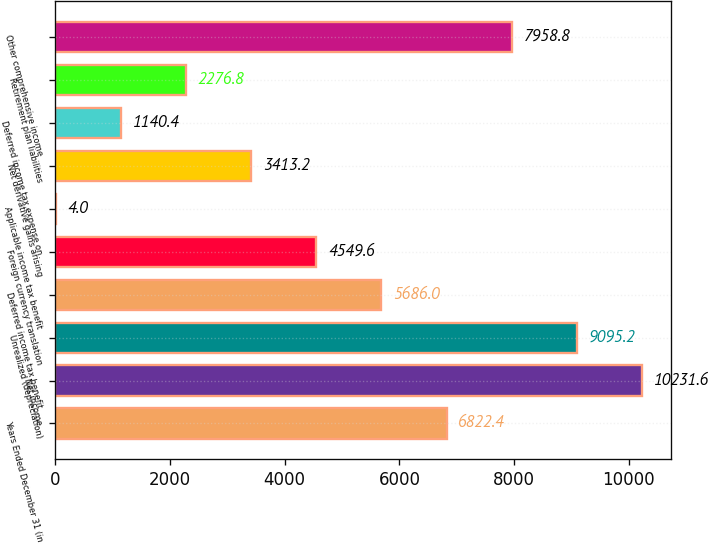Convert chart. <chart><loc_0><loc_0><loc_500><loc_500><bar_chart><fcel>Years Ended December 31 (in<fcel>Net income<fcel>Unrealized (depreciation)<fcel>Deferred income tax benefit<fcel>Foreign currency translation<fcel>Applicable income tax benefit<fcel>Net derivative gains arising<fcel>Deferred income tax expense on<fcel>Retirement plan liabilities<fcel>Other comprehensive income<nl><fcel>6822.4<fcel>10231.6<fcel>9095.2<fcel>5686<fcel>4549.6<fcel>4<fcel>3413.2<fcel>1140.4<fcel>2276.8<fcel>7958.8<nl></chart> 